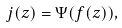Convert formula to latex. <formula><loc_0><loc_0><loc_500><loc_500>j ( z ) = \Psi ( f ( z ) ) ,</formula> 